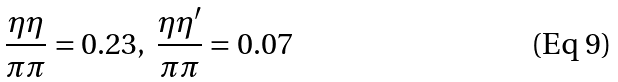<formula> <loc_0><loc_0><loc_500><loc_500>\frac { \eta \eta } { \pi \pi } = 0 . 2 3 , \ \frac { \eta \eta ^ { \prime } } { \pi \pi } = 0 . 0 7</formula> 